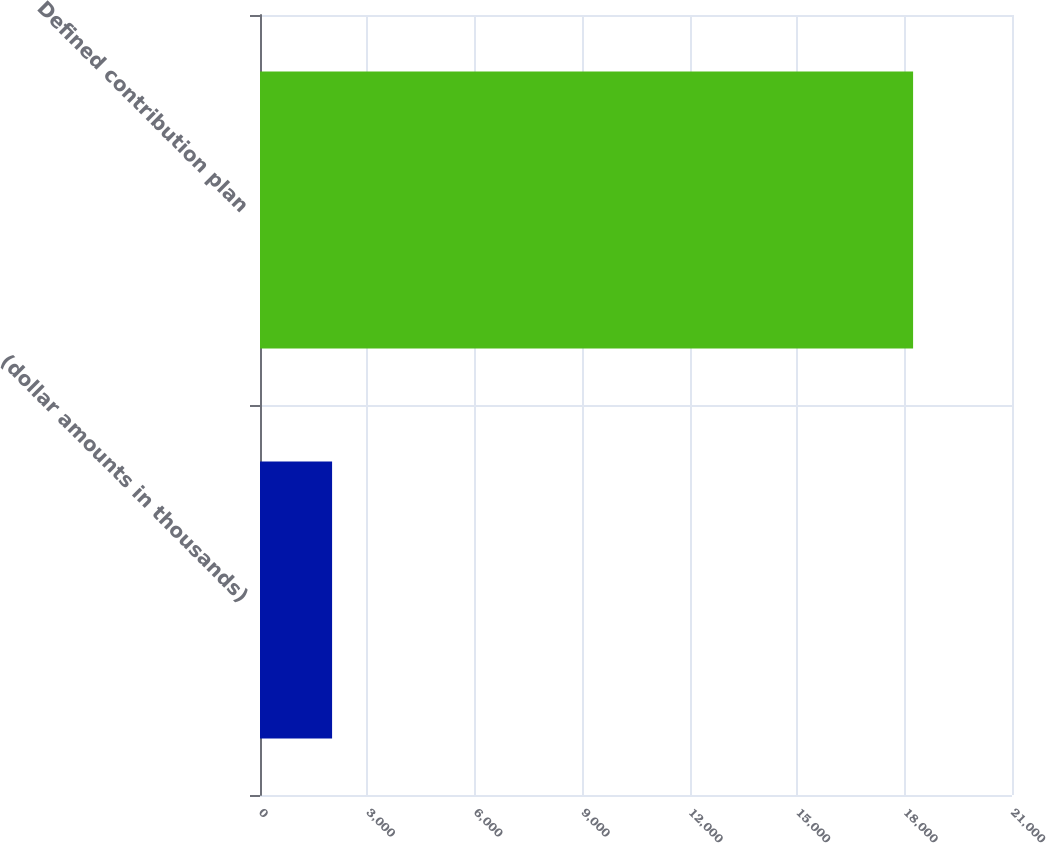Convert chart. <chart><loc_0><loc_0><loc_500><loc_500><bar_chart><fcel>(dollar amounts in thousands)<fcel>Defined contribution plan<nl><fcel>2013<fcel>18238<nl></chart> 